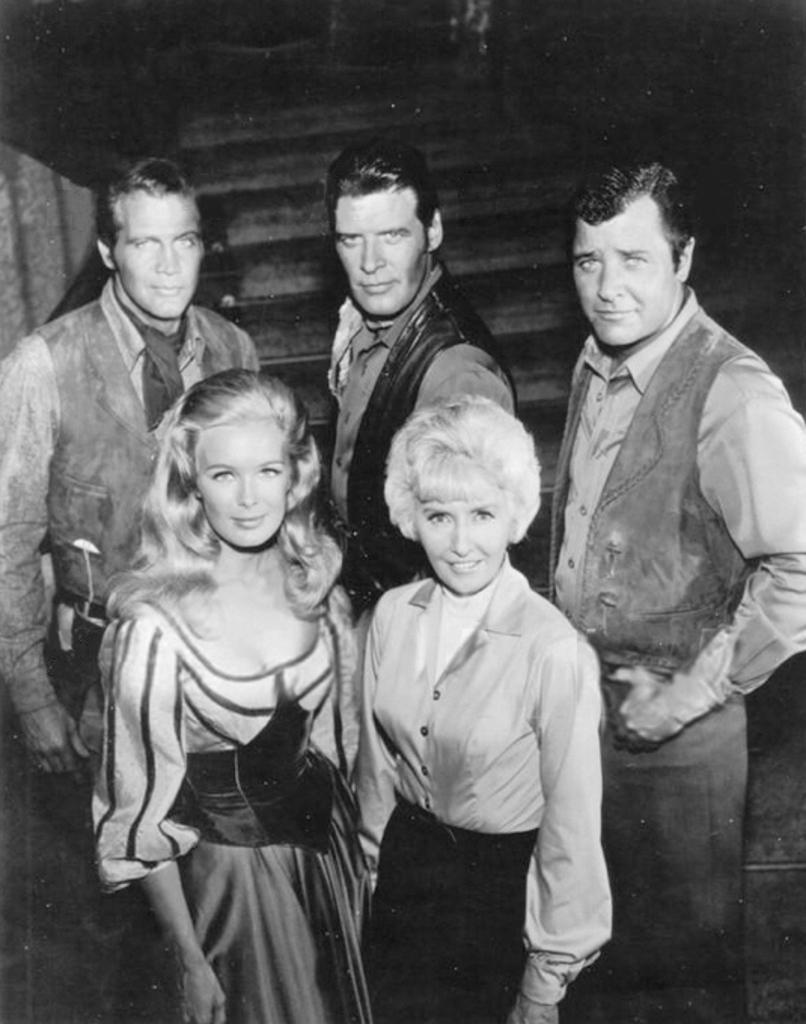Could you give a brief overview of what you see in this image? In this image we can see a group of people standing. 